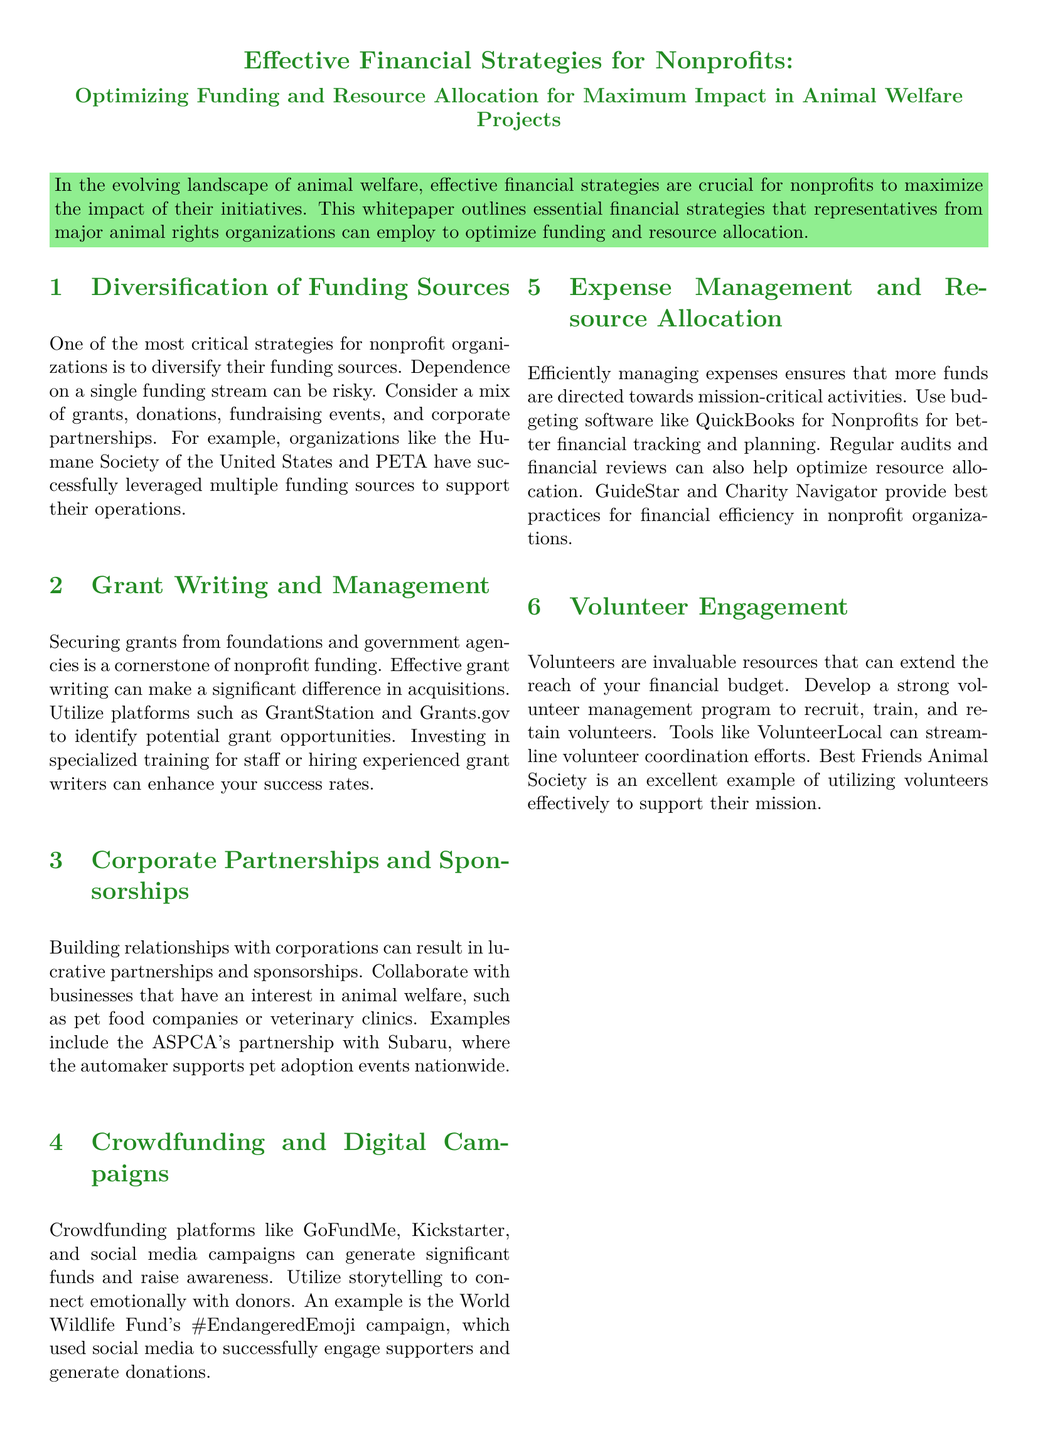What is the main topic of the whitepaper? The main topic discusses effective financial strategies for nonprofits in the context of animal welfare projects.
Answer: Effective Financial Strategies for Nonprofits What is one critical strategy for nonprofits? The document highlights that diversifying funding sources is crucial for nonprofit organizations.
Answer: Diversification of Funding Sources Which platform is mentioned for identifying grant opportunities? The document references GrantStation and Grants.gov as platforms to find potential grants.
Answer: GrantStation and Grants.gov What is one example of a successful corporate partnership? The whitepaper mentions the ASPCA's partnership with Subaru as a successful collaboration.
Answer: ASPCA's partnership with Subaru What budgeting software is suggested for nonprofits? The document recommends using QuickBooks for Nonprofits to manage expenses better.
Answer: QuickBooks for Nonprofits What is an effective way to engage supporters through digital campaigns? The whitepaper suggests using storytelling to emotionally connect with donors in digital campaigns.
Answer: Storytelling Which animal rights organization is noted for utilizing volunteers effectively? Best Friends Animal Society is highlighted as an example of effective volunteer utilization.
Answer: Best Friends Animal Society What is the end goal of implementing these financial strategies? The ultimate goal is to increase the impact of animal welfare nonprofits through sustainable growth.
Answer: Increase impact 